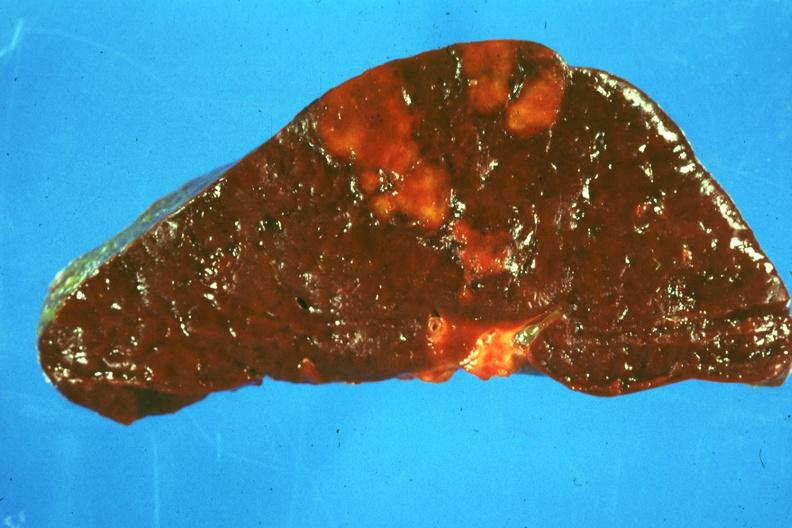what is present?
Answer the question using a single word or phrase. Hematologic 